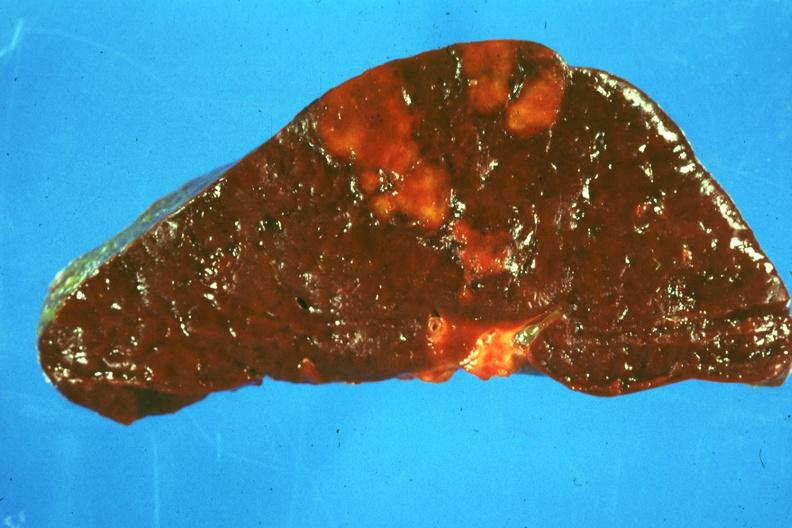what is present?
Answer the question using a single word or phrase. Hematologic 